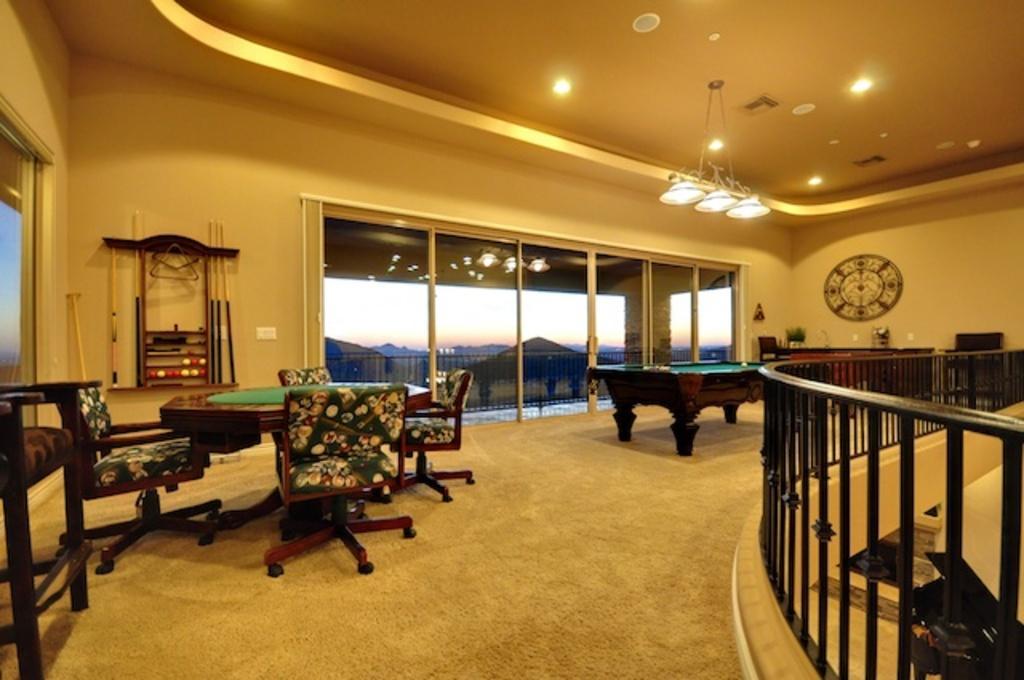In one or two sentences, can you explain what this image depicts? In the image we can see there are chair and table in a room and there is a billiard board and there are balls and sticks. 